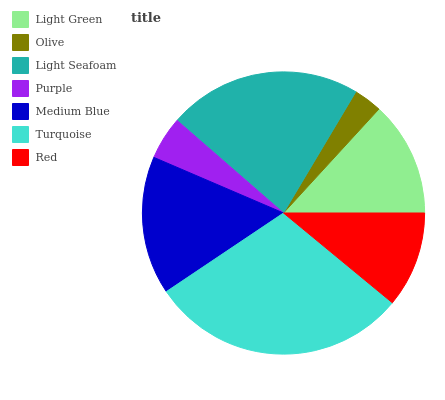Is Olive the minimum?
Answer yes or no. Yes. Is Turquoise the maximum?
Answer yes or no. Yes. Is Light Seafoam the minimum?
Answer yes or no. No. Is Light Seafoam the maximum?
Answer yes or no. No. Is Light Seafoam greater than Olive?
Answer yes or no. Yes. Is Olive less than Light Seafoam?
Answer yes or no. Yes. Is Olive greater than Light Seafoam?
Answer yes or no. No. Is Light Seafoam less than Olive?
Answer yes or no. No. Is Light Green the high median?
Answer yes or no. Yes. Is Light Green the low median?
Answer yes or no. Yes. Is Medium Blue the high median?
Answer yes or no. No. Is Light Seafoam the low median?
Answer yes or no. No. 